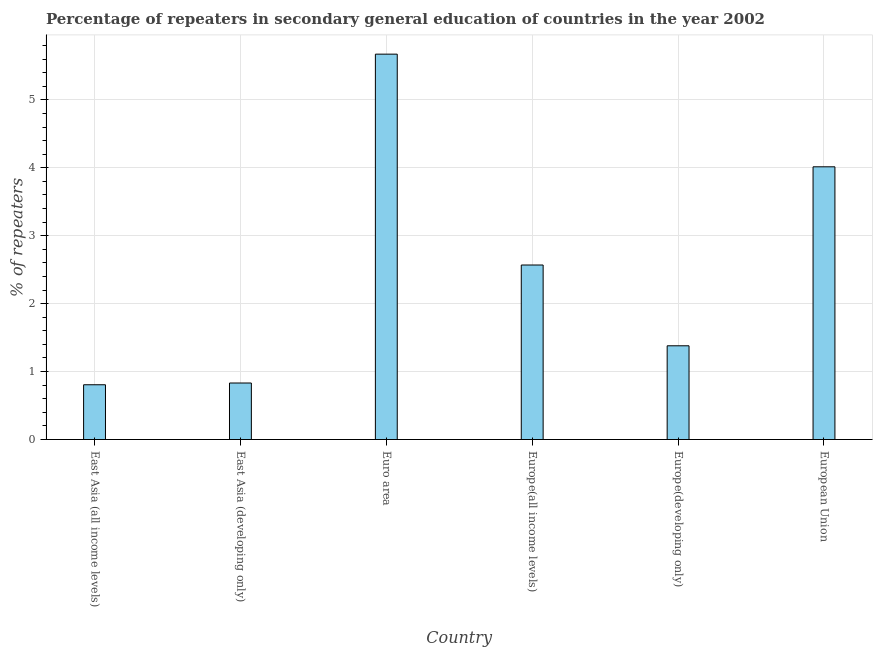Does the graph contain grids?
Make the answer very short. Yes. What is the title of the graph?
Give a very brief answer. Percentage of repeaters in secondary general education of countries in the year 2002. What is the label or title of the Y-axis?
Provide a succinct answer. % of repeaters. What is the percentage of repeaters in East Asia (all income levels)?
Provide a short and direct response. 0.81. Across all countries, what is the maximum percentage of repeaters?
Your response must be concise. 5.67. Across all countries, what is the minimum percentage of repeaters?
Provide a short and direct response. 0.81. In which country was the percentage of repeaters minimum?
Make the answer very short. East Asia (all income levels). What is the sum of the percentage of repeaters?
Ensure brevity in your answer.  15.27. What is the difference between the percentage of repeaters in Europe(developing only) and European Union?
Your answer should be compact. -2.63. What is the average percentage of repeaters per country?
Provide a succinct answer. 2.55. What is the median percentage of repeaters?
Provide a succinct answer. 1.97. In how many countries, is the percentage of repeaters greater than 1.4 %?
Provide a short and direct response. 3. What is the ratio of the percentage of repeaters in Europe(developing only) to that in European Union?
Keep it short and to the point. 0.34. Is the percentage of repeaters in East Asia (developing only) less than that in European Union?
Your answer should be compact. Yes. Is the difference between the percentage of repeaters in Europe(all income levels) and European Union greater than the difference between any two countries?
Make the answer very short. No. What is the difference between the highest and the second highest percentage of repeaters?
Keep it short and to the point. 1.66. Is the sum of the percentage of repeaters in East Asia (all income levels) and Euro area greater than the maximum percentage of repeaters across all countries?
Keep it short and to the point. Yes. What is the difference between the highest and the lowest percentage of repeaters?
Provide a succinct answer. 4.87. In how many countries, is the percentage of repeaters greater than the average percentage of repeaters taken over all countries?
Your answer should be very brief. 3. How many bars are there?
Make the answer very short. 6. Are all the bars in the graph horizontal?
Keep it short and to the point. No. How many countries are there in the graph?
Keep it short and to the point. 6. What is the difference between two consecutive major ticks on the Y-axis?
Your answer should be compact. 1. What is the % of repeaters of East Asia (all income levels)?
Keep it short and to the point. 0.81. What is the % of repeaters of East Asia (developing only)?
Provide a short and direct response. 0.83. What is the % of repeaters of Euro area?
Ensure brevity in your answer.  5.67. What is the % of repeaters in Europe(all income levels)?
Provide a succinct answer. 2.57. What is the % of repeaters in Europe(developing only)?
Provide a succinct answer. 1.38. What is the % of repeaters in European Union?
Make the answer very short. 4.01. What is the difference between the % of repeaters in East Asia (all income levels) and East Asia (developing only)?
Ensure brevity in your answer.  -0.03. What is the difference between the % of repeaters in East Asia (all income levels) and Euro area?
Provide a short and direct response. -4.87. What is the difference between the % of repeaters in East Asia (all income levels) and Europe(all income levels)?
Give a very brief answer. -1.76. What is the difference between the % of repeaters in East Asia (all income levels) and Europe(developing only)?
Ensure brevity in your answer.  -0.57. What is the difference between the % of repeaters in East Asia (all income levels) and European Union?
Your answer should be compact. -3.21. What is the difference between the % of repeaters in East Asia (developing only) and Euro area?
Give a very brief answer. -4.84. What is the difference between the % of repeaters in East Asia (developing only) and Europe(all income levels)?
Ensure brevity in your answer.  -1.74. What is the difference between the % of repeaters in East Asia (developing only) and Europe(developing only)?
Your response must be concise. -0.55. What is the difference between the % of repeaters in East Asia (developing only) and European Union?
Your answer should be very brief. -3.18. What is the difference between the % of repeaters in Euro area and Europe(all income levels)?
Your answer should be compact. 3.1. What is the difference between the % of repeaters in Euro area and Europe(developing only)?
Your response must be concise. 4.29. What is the difference between the % of repeaters in Euro area and European Union?
Provide a succinct answer. 1.66. What is the difference between the % of repeaters in Europe(all income levels) and Europe(developing only)?
Offer a very short reply. 1.19. What is the difference between the % of repeaters in Europe(all income levels) and European Union?
Your answer should be very brief. -1.45. What is the difference between the % of repeaters in Europe(developing only) and European Union?
Offer a very short reply. -2.63. What is the ratio of the % of repeaters in East Asia (all income levels) to that in East Asia (developing only)?
Your answer should be very brief. 0.97. What is the ratio of the % of repeaters in East Asia (all income levels) to that in Euro area?
Your answer should be very brief. 0.14. What is the ratio of the % of repeaters in East Asia (all income levels) to that in Europe(all income levels)?
Your response must be concise. 0.31. What is the ratio of the % of repeaters in East Asia (all income levels) to that in Europe(developing only)?
Provide a short and direct response. 0.58. What is the ratio of the % of repeaters in East Asia (all income levels) to that in European Union?
Make the answer very short. 0.2. What is the ratio of the % of repeaters in East Asia (developing only) to that in Euro area?
Offer a very short reply. 0.15. What is the ratio of the % of repeaters in East Asia (developing only) to that in Europe(all income levels)?
Your answer should be very brief. 0.32. What is the ratio of the % of repeaters in East Asia (developing only) to that in Europe(developing only)?
Offer a terse response. 0.6. What is the ratio of the % of repeaters in East Asia (developing only) to that in European Union?
Ensure brevity in your answer.  0.21. What is the ratio of the % of repeaters in Euro area to that in Europe(all income levels)?
Ensure brevity in your answer.  2.21. What is the ratio of the % of repeaters in Euro area to that in Europe(developing only)?
Your answer should be very brief. 4.11. What is the ratio of the % of repeaters in Euro area to that in European Union?
Provide a succinct answer. 1.41. What is the ratio of the % of repeaters in Europe(all income levels) to that in Europe(developing only)?
Your answer should be very brief. 1.86. What is the ratio of the % of repeaters in Europe(all income levels) to that in European Union?
Provide a succinct answer. 0.64. What is the ratio of the % of repeaters in Europe(developing only) to that in European Union?
Offer a very short reply. 0.34. 